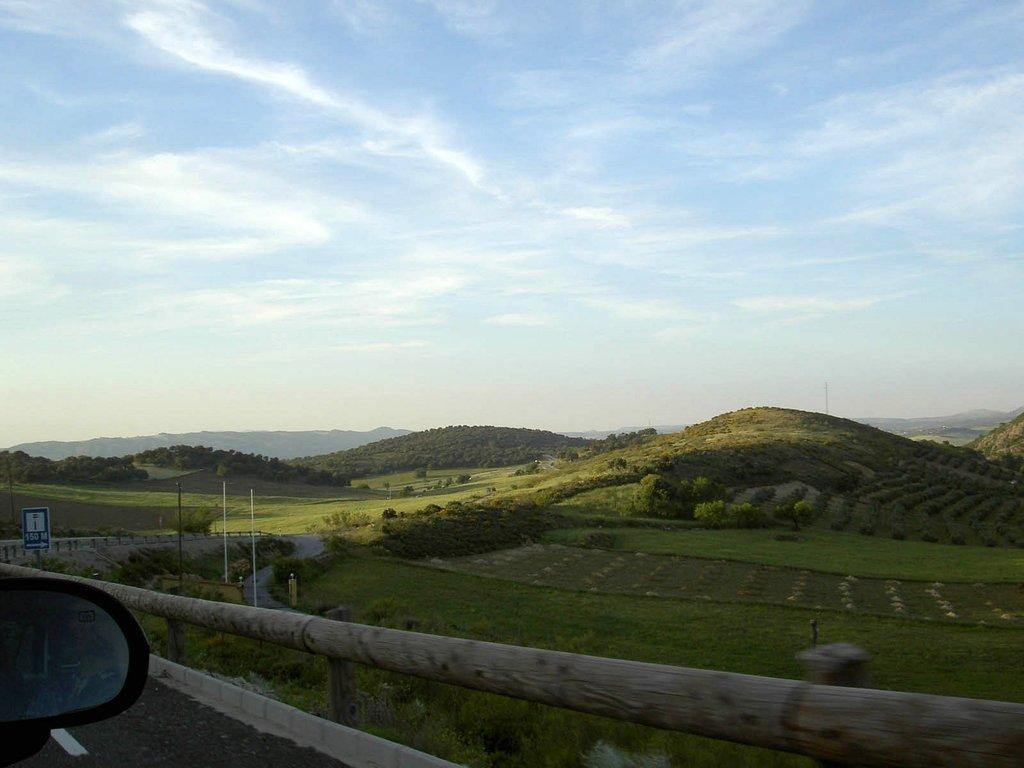What is located at the front of the image? There is a fence in the front of the image. What is next to the fence? There is a car beside the fence. What can be seen in the background of the image? There are hills covered with plants and trees in the background of the image. What is visible above the hills and the car? The sky is visible in the image. What can be observed in the sky? Clouds are present in the sky. Can you hear the voice of the apples in the image? There are no apples present in the image, and therefore no voice can be heard. How does the touch of the fence feel in the image? The image is a visual representation and does not convey tactile sensations, so it is not possible to determine how the fence feels to the touch. 